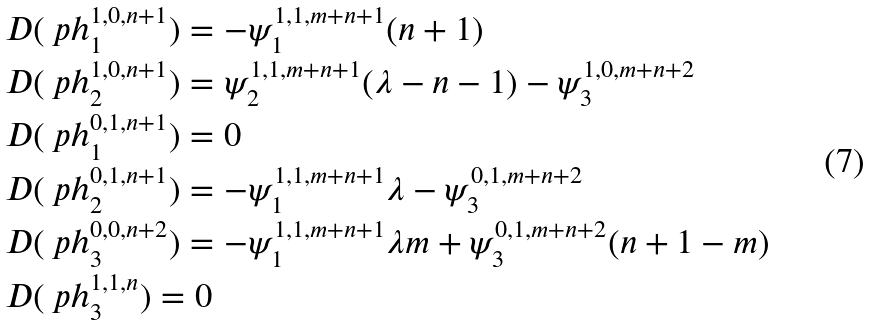<formula> <loc_0><loc_0><loc_500><loc_500>& D ( \ p h ^ { 1 , 0 , n + 1 } _ { 1 } ) = - \psi ^ { 1 , 1 , m + n + 1 } _ { 1 } ( n + 1 ) \\ & D ( \ p h ^ { 1 , 0 , n + 1 } _ { 2 } ) = \psi ^ { 1 , 1 , m + n + 1 } _ { 2 } ( \lambda - n - 1 ) - \psi ^ { 1 , 0 , m + n + 2 } _ { 3 } \\ & D ( \ p h ^ { 0 , 1 , n + 1 } _ { 1 } ) = 0 \\ & D ( \ p h ^ { 0 , 1 , n + 1 } _ { 2 } ) = - \psi ^ { 1 , 1 , m + n + 1 } _ { 1 } \lambda - \psi ^ { 0 , 1 , m + n + 2 } _ { 3 } \\ & D ( \ p h ^ { 0 , 0 , n + 2 } _ { 3 } ) = - \psi ^ { 1 , 1 , m + n + 1 } _ { 1 } \lambda m + \psi ^ { 0 , 1 , m + n + 2 } _ { 3 } ( n + 1 - m ) \\ & D ( \ p h ^ { 1 , 1 , n } _ { 3 } ) = 0 \\</formula> 